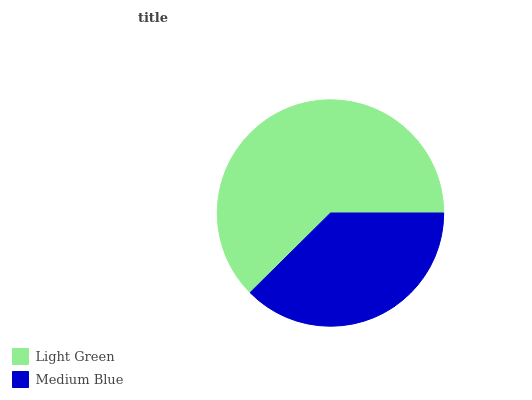Is Medium Blue the minimum?
Answer yes or no. Yes. Is Light Green the maximum?
Answer yes or no. Yes. Is Medium Blue the maximum?
Answer yes or no. No. Is Light Green greater than Medium Blue?
Answer yes or no. Yes. Is Medium Blue less than Light Green?
Answer yes or no. Yes. Is Medium Blue greater than Light Green?
Answer yes or no. No. Is Light Green less than Medium Blue?
Answer yes or no. No. Is Light Green the high median?
Answer yes or no. Yes. Is Medium Blue the low median?
Answer yes or no. Yes. Is Medium Blue the high median?
Answer yes or no. No. Is Light Green the low median?
Answer yes or no. No. 